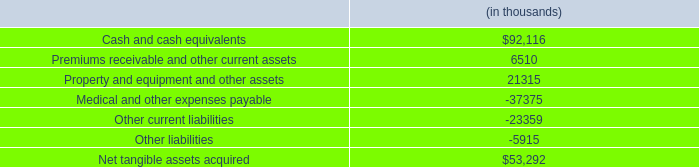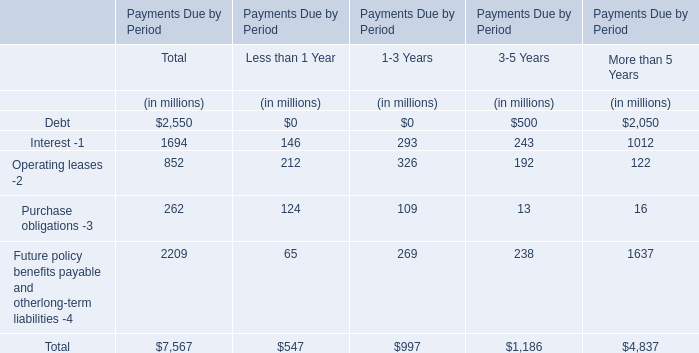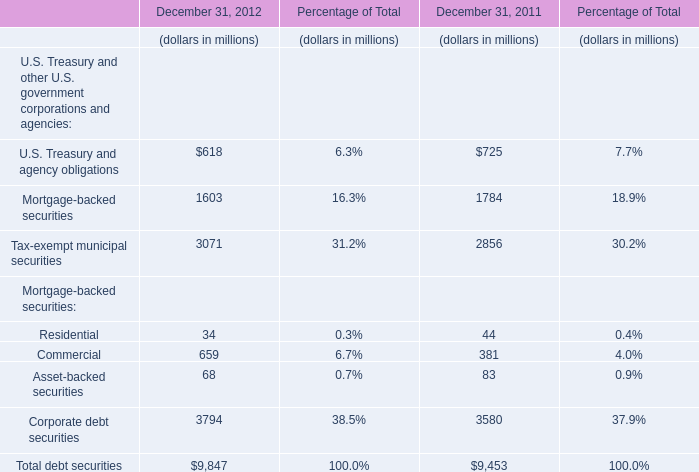In the year with largest amount of Residential , what's the sum of Mortgage-backed securities? (in million) 
Computations: (((44 + 83) + 381) + 3580)
Answer: 4088.0. 